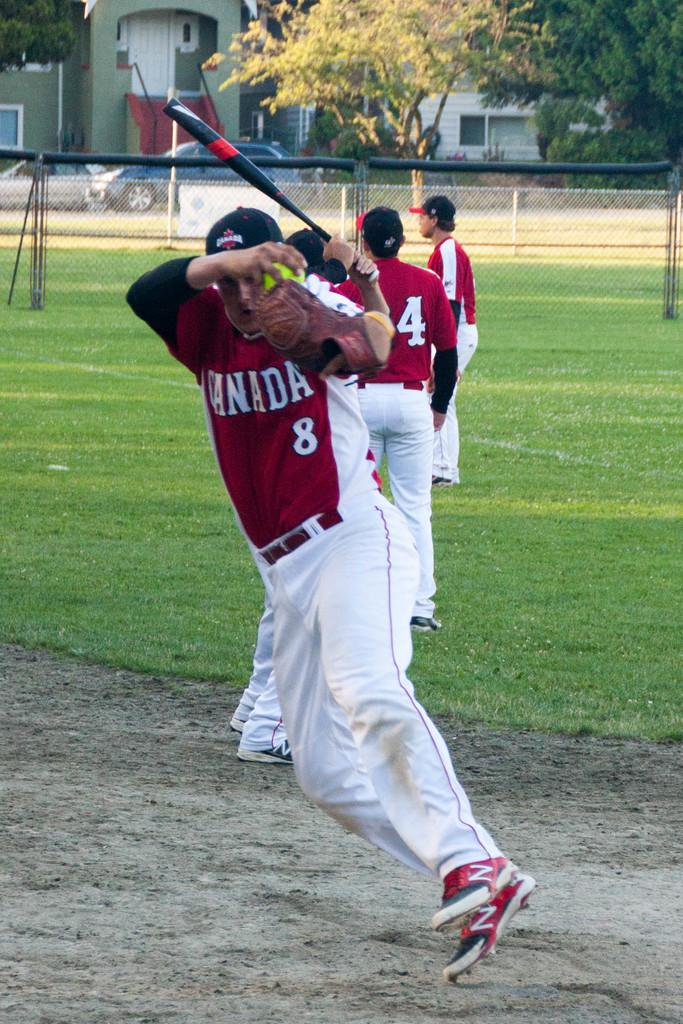<image>
Render a clear and concise summary of the photo. a group of players with one wearing the number 8 